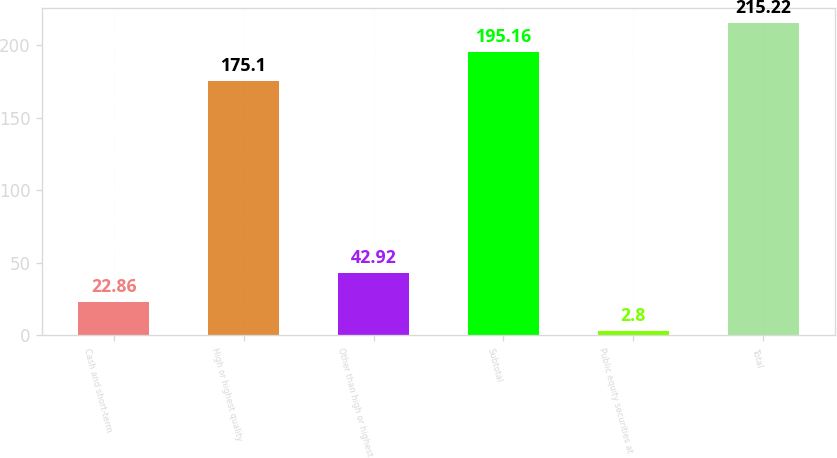<chart> <loc_0><loc_0><loc_500><loc_500><bar_chart><fcel>Cash and short-term<fcel>High or highest quality<fcel>Other than high or highest<fcel>Subtotal<fcel>Public equity securities at<fcel>Total<nl><fcel>22.86<fcel>175.1<fcel>42.92<fcel>195.16<fcel>2.8<fcel>215.22<nl></chart> 